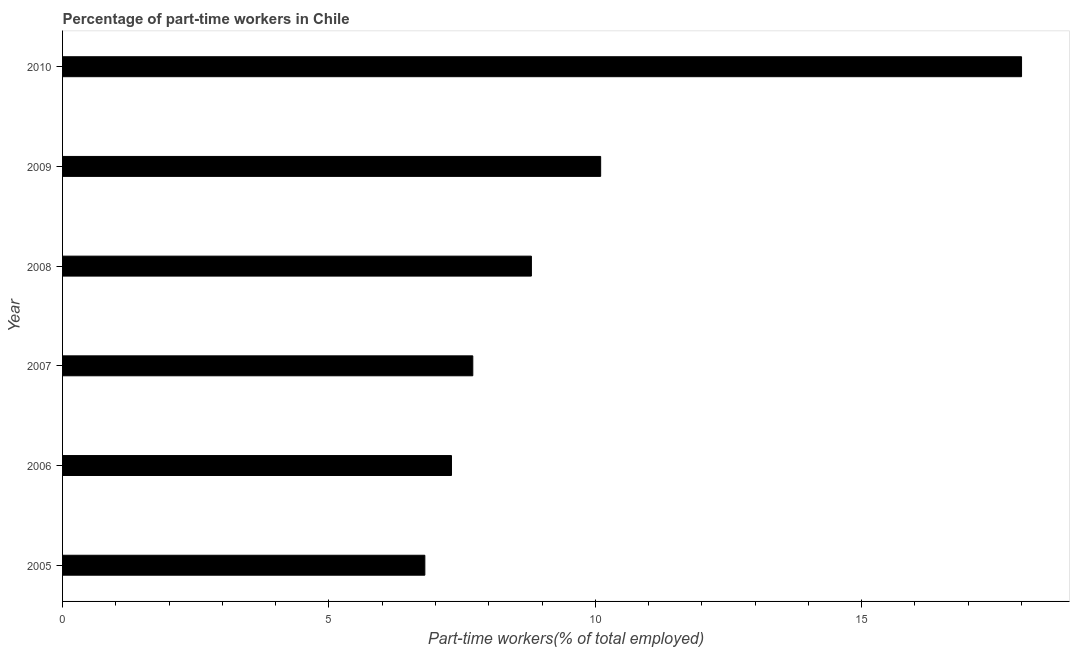Does the graph contain grids?
Give a very brief answer. No. What is the title of the graph?
Your answer should be very brief. Percentage of part-time workers in Chile. What is the label or title of the X-axis?
Your answer should be very brief. Part-time workers(% of total employed). What is the percentage of part-time workers in 2006?
Keep it short and to the point. 7.3. Across all years, what is the minimum percentage of part-time workers?
Provide a succinct answer. 6.8. In which year was the percentage of part-time workers maximum?
Make the answer very short. 2010. In which year was the percentage of part-time workers minimum?
Provide a succinct answer. 2005. What is the sum of the percentage of part-time workers?
Your response must be concise. 58.7. What is the difference between the percentage of part-time workers in 2008 and 2009?
Give a very brief answer. -1.3. What is the average percentage of part-time workers per year?
Keep it short and to the point. 9.78. What is the median percentage of part-time workers?
Make the answer very short. 8.25. Do a majority of the years between 2009 and 2007 (inclusive) have percentage of part-time workers greater than 11 %?
Provide a succinct answer. Yes. What is the ratio of the percentage of part-time workers in 2007 to that in 2009?
Your answer should be very brief. 0.76. Is the percentage of part-time workers in 2005 less than that in 2006?
Provide a succinct answer. Yes. What is the difference between the highest and the second highest percentage of part-time workers?
Provide a succinct answer. 7.9. Is the sum of the percentage of part-time workers in 2007 and 2009 greater than the maximum percentage of part-time workers across all years?
Your answer should be compact. No. What is the difference between two consecutive major ticks on the X-axis?
Your answer should be very brief. 5. What is the Part-time workers(% of total employed) of 2005?
Offer a very short reply. 6.8. What is the Part-time workers(% of total employed) of 2006?
Keep it short and to the point. 7.3. What is the Part-time workers(% of total employed) in 2007?
Offer a very short reply. 7.7. What is the Part-time workers(% of total employed) in 2008?
Provide a short and direct response. 8.8. What is the Part-time workers(% of total employed) in 2009?
Your answer should be compact. 10.1. What is the Part-time workers(% of total employed) of 2010?
Provide a succinct answer. 18. What is the difference between the Part-time workers(% of total employed) in 2005 and 2008?
Ensure brevity in your answer.  -2. What is the difference between the Part-time workers(% of total employed) in 2005 and 2009?
Your answer should be compact. -3.3. What is the difference between the Part-time workers(% of total employed) in 2005 and 2010?
Your answer should be very brief. -11.2. What is the difference between the Part-time workers(% of total employed) in 2006 and 2008?
Make the answer very short. -1.5. What is the difference between the Part-time workers(% of total employed) in 2008 and 2009?
Offer a terse response. -1.3. What is the difference between the Part-time workers(% of total employed) in 2009 and 2010?
Provide a succinct answer. -7.9. What is the ratio of the Part-time workers(% of total employed) in 2005 to that in 2006?
Give a very brief answer. 0.93. What is the ratio of the Part-time workers(% of total employed) in 2005 to that in 2007?
Offer a terse response. 0.88. What is the ratio of the Part-time workers(% of total employed) in 2005 to that in 2008?
Provide a succinct answer. 0.77. What is the ratio of the Part-time workers(% of total employed) in 2005 to that in 2009?
Offer a very short reply. 0.67. What is the ratio of the Part-time workers(% of total employed) in 2005 to that in 2010?
Make the answer very short. 0.38. What is the ratio of the Part-time workers(% of total employed) in 2006 to that in 2007?
Ensure brevity in your answer.  0.95. What is the ratio of the Part-time workers(% of total employed) in 2006 to that in 2008?
Provide a succinct answer. 0.83. What is the ratio of the Part-time workers(% of total employed) in 2006 to that in 2009?
Your response must be concise. 0.72. What is the ratio of the Part-time workers(% of total employed) in 2006 to that in 2010?
Make the answer very short. 0.41. What is the ratio of the Part-time workers(% of total employed) in 2007 to that in 2008?
Give a very brief answer. 0.88. What is the ratio of the Part-time workers(% of total employed) in 2007 to that in 2009?
Your response must be concise. 0.76. What is the ratio of the Part-time workers(% of total employed) in 2007 to that in 2010?
Your answer should be compact. 0.43. What is the ratio of the Part-time workers(% of total employed) in 2008 to that in 2009?
Keep it short and to the point. 0.87. What is the ratio of the Part-time workers(% of total employed) in 2008 to that in 2010?
Offer a terse response. 0.49. What is the ratio of the Part-time workers(% of total employed) in 2009 to that in 2010?
Offer a terse response. 0.56. 